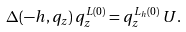Convert formula to latex. <formula><loc_0><loc_0><loc_500><loc_500>\Delta ( - h , q _ { z } ) \, q _ { z } ^ { L ( 0 ) } = q _ { z } ^ { L _ { h } ( 0 ) } \, U .</formula> 